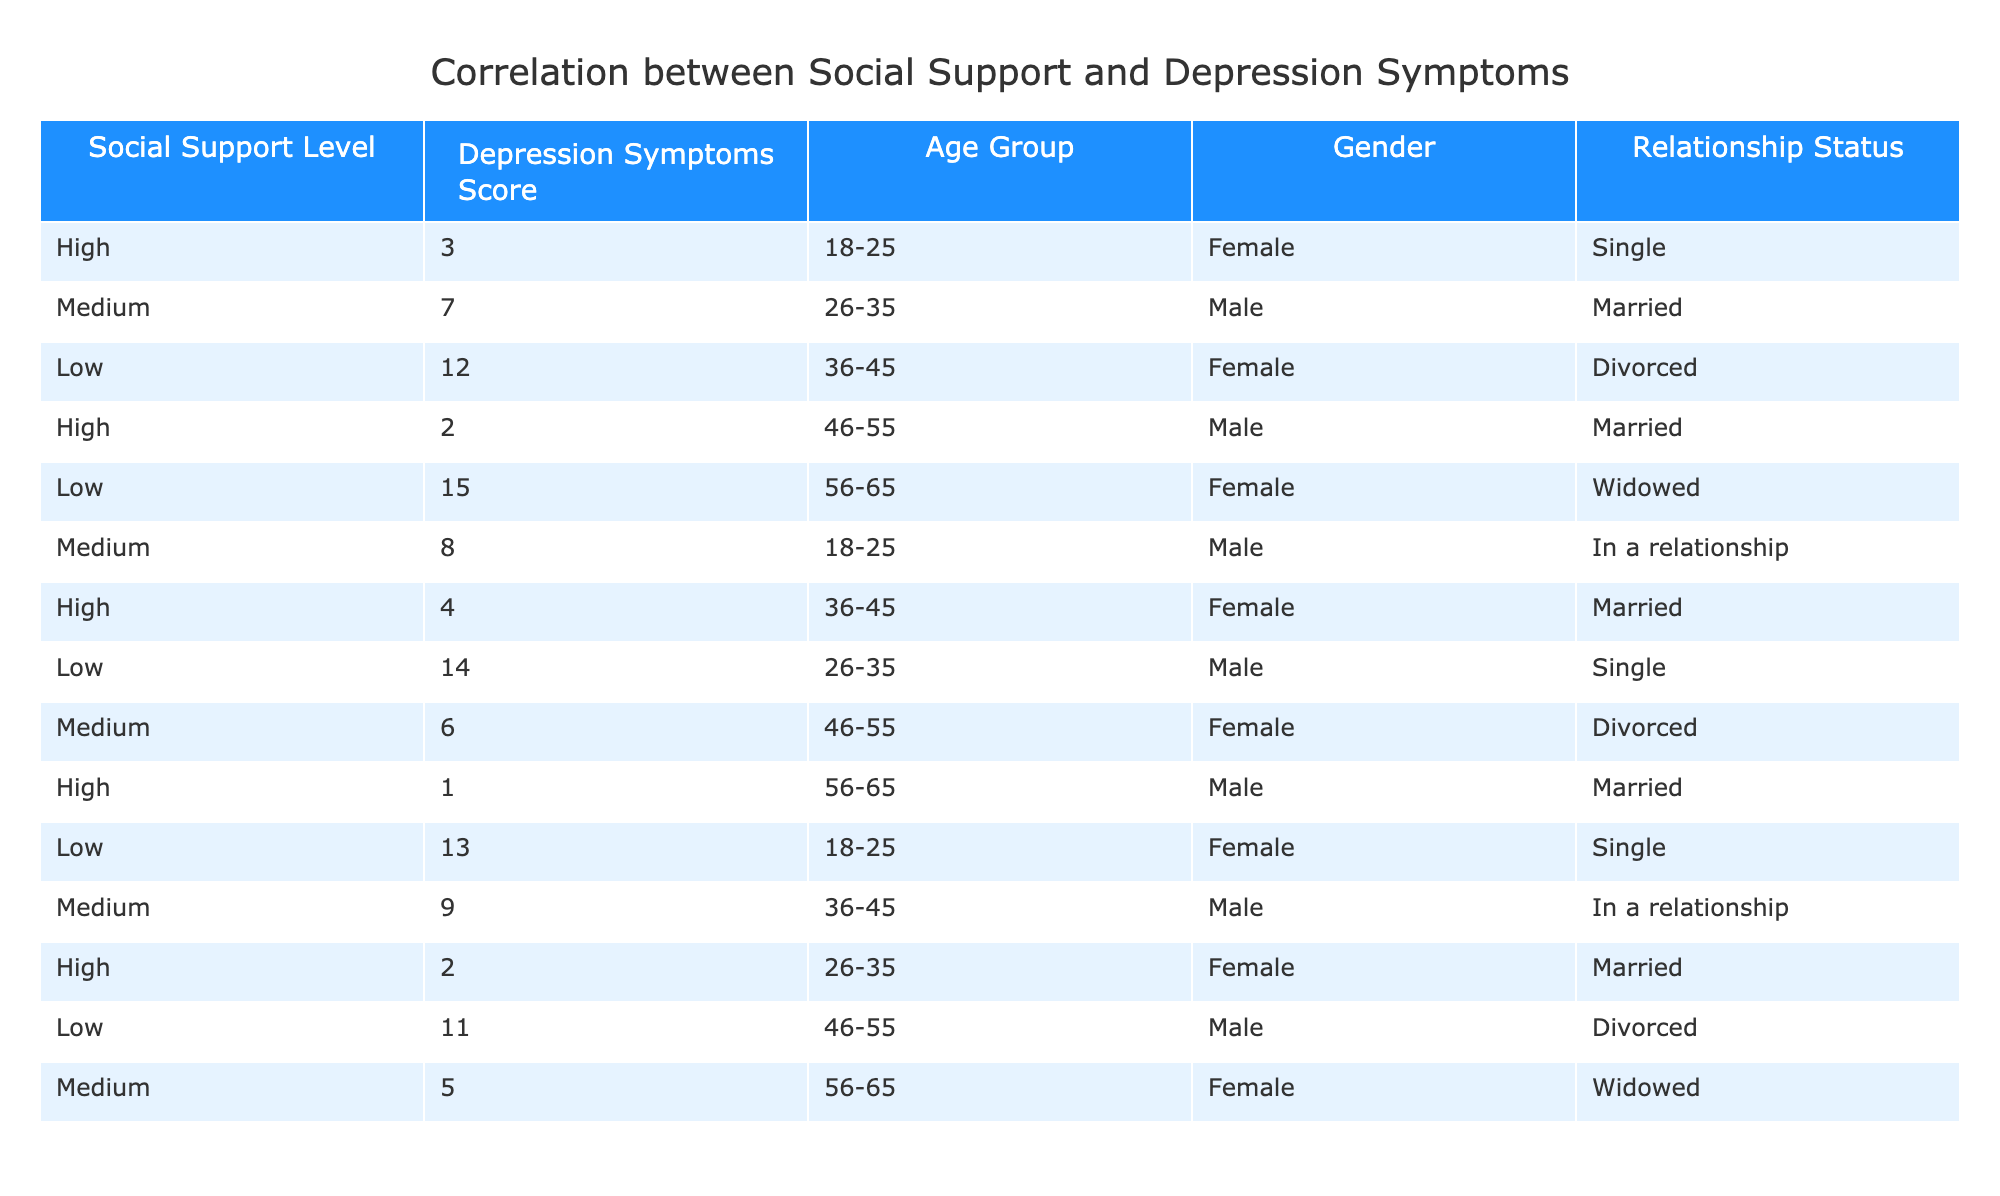What is the depression symptoms score for individuals with high social support? There are three entries with a high social support level. Their depression symptoms scores are 3, 2, and 1. The values are 3, 2, and 1.
Answer: 1, 2, 3 How many individuals have a low depression symptoms score? The individuals with low depression symptoms scores are from high, medium, and low categories. For low score, the values are 12, 15, 14, 13, and 11. Thus there are 5 individuals with low scores.
Answer: 5 Is there anyone in the table with a low social support score and a depression symptoms score of 14? Scanning the table, we see an entry for a low social support score with a depression symptoms score of 14. Therefore, yes, there is such an individual.
Answer: Yes What is the average depression symptoms score for females in the younger age group (18-25)? In the age group of 18-25, the females have depression scores of 3 and 13. Summing these gives 3 + 13 = 16. There are 2 entries, so the average is 16 / 2 = 8.
Answer: 8 How does the depression score of married males compare to that of single males? Married males have depression scores of 7, 2, and 1 (totaling to 10), and single males have scores of 14. Comparing, singles have a higher score by 14 - 10 = 4.
Answer: 4 What is the total number of individuals in the 36-45 age group with medium social support? In the 36-45 age group, we check for medium social support levels. The score listed is only 6, indicating just one individual.
Answer: 1 